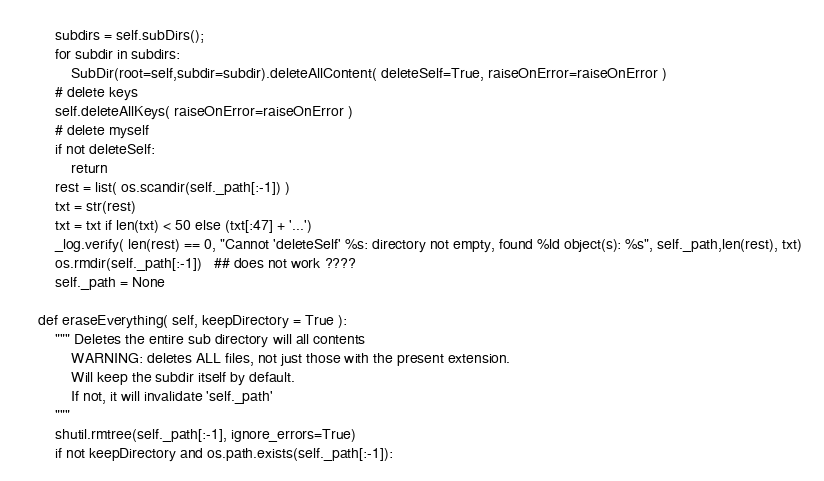<code> <loc_0><loc_0><loc_500><loc_500><_Python_>        subdirs = self.subDirs();
        for subdir in subdirs:
            SubDir(root=self,subdir=subdir).deleteAllContent( deleteSelf=True, raiseOnError=raiseOnError )
        # delete keys
        self.deleteAllKeys( raiseOnError=raiseOnError )
        # delete myself    
        if not deleteSelf:
            return
        rest = list( os.scandir(self._path[:-1]) )
        txt = str(rest)
        txt = txt if len(txt) < 50 else (txt[:47] + '...')
        _log.verify( len(rest) == 0, "Cannot 'deleteSelf' %s: directory not empty, found %ld object(s): %s", self._path,len(rest), txt)
        os.rmdir(self._path[:-1])   ## does not work ????
        self._path = None
            
    def eraseEverything( self, keepDirectory = True ):
        """ Deletes the entire sub directory will all contents
            WARNING: deletes ALL files, not just those with the present extension.
            Will keep the subdir itself by default.
            If not, it will invalidate 'self._path'
        """
        shutil.rmtree(self._path[:-1], ignore_errors=True)
        if not keepDirectory and os.path.exists(self._path[:-1]):</code> 